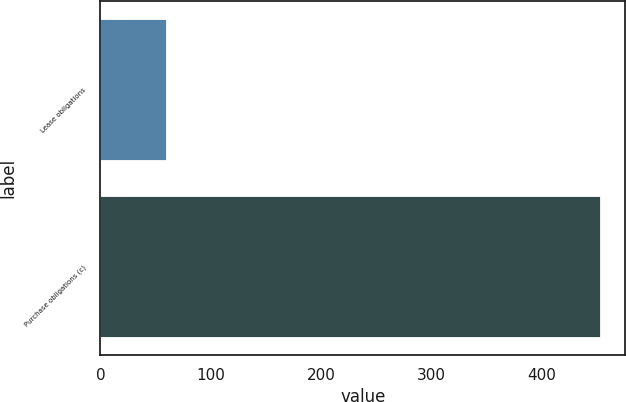Convert chart. <chart><loc_0><loc_0><loc_500><loc_500><bar_chart><fcel>Lease obligations<fcel>Purchase obligations (c)<nl><fcel>59<fcel>453<nl></chart> 